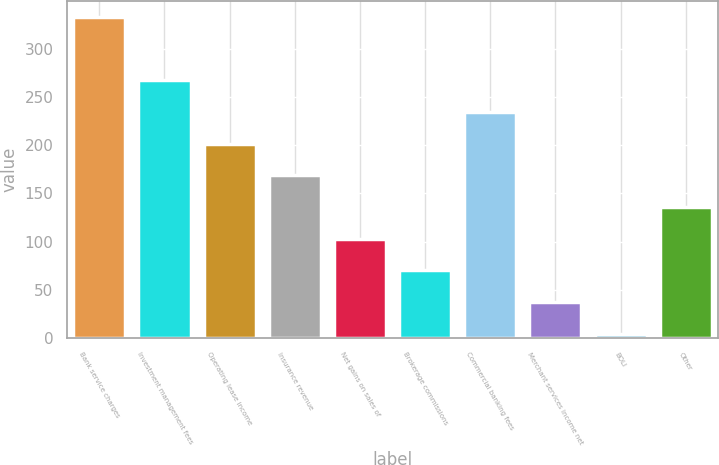Convert chart to OTSL. <chart><loc_0><loc_0><loc_500><loc_500><bar_chart><fcel>Bank service charges<fcel>Investment management fees<fcel>Operating lease income<fcel>Insurance revenue<fcel>Net gains on sales of<fcel>Brokerage commissions<fcel>Commercial banking fees<fcel>Merchant services income net<fcel>BOLI<fcel>Other<nl><fcel>333.2<fcel>267.46<fcel>201.72<fcel>168.85<fcel>103.11<fcel>70.24<fcel>234.59<fcel>37.37<fcel>4.5<fcel>135.98<nl></chart> 